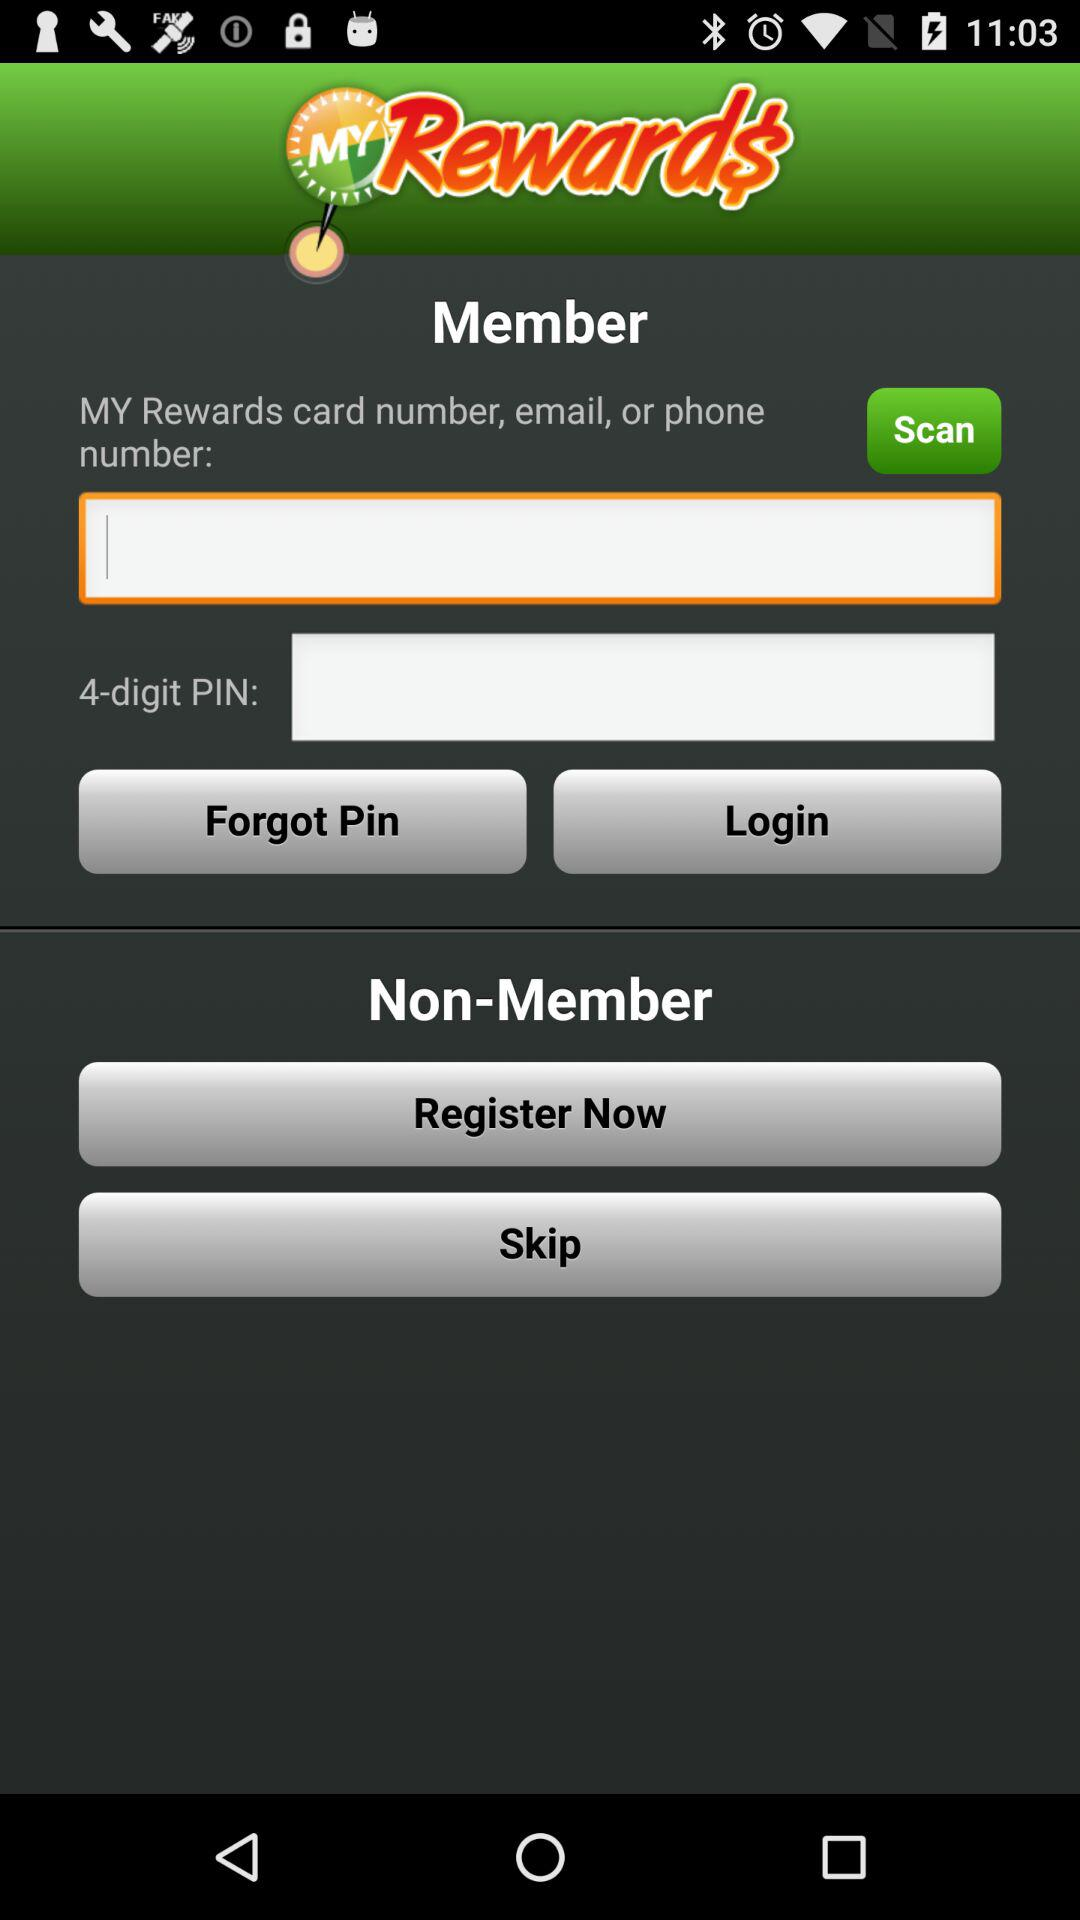What is the name of the application? The name of the application is "MYRewards". 